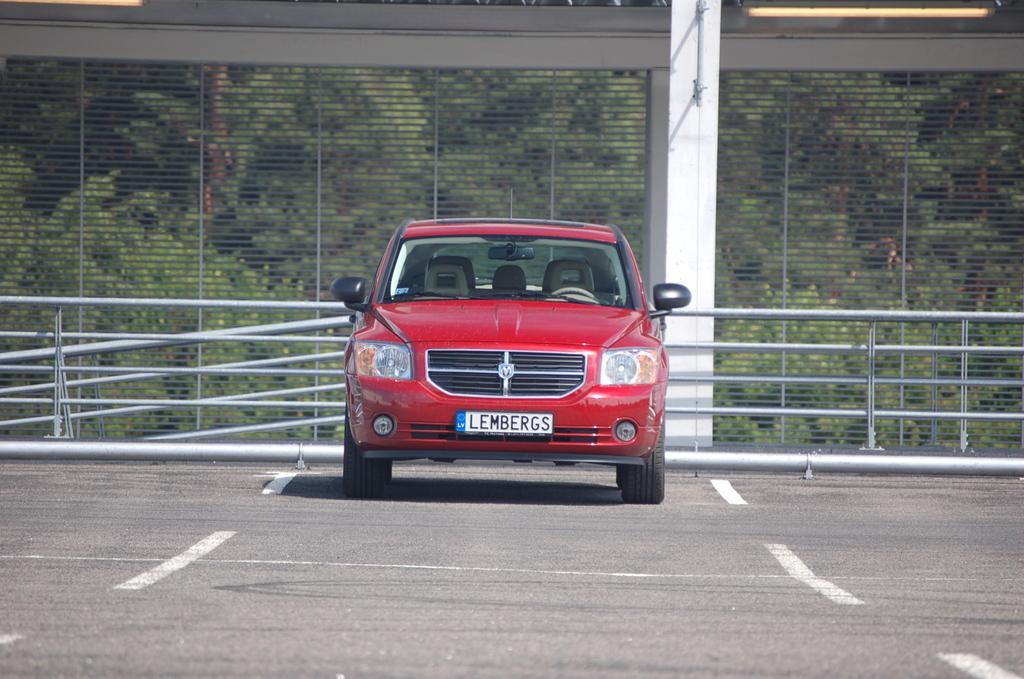How would you summarize this image in a sentence or two? In this picture there is a red color car in the center of the image and there is a boundary in the center of the image, there are trees in the background area of the image. 